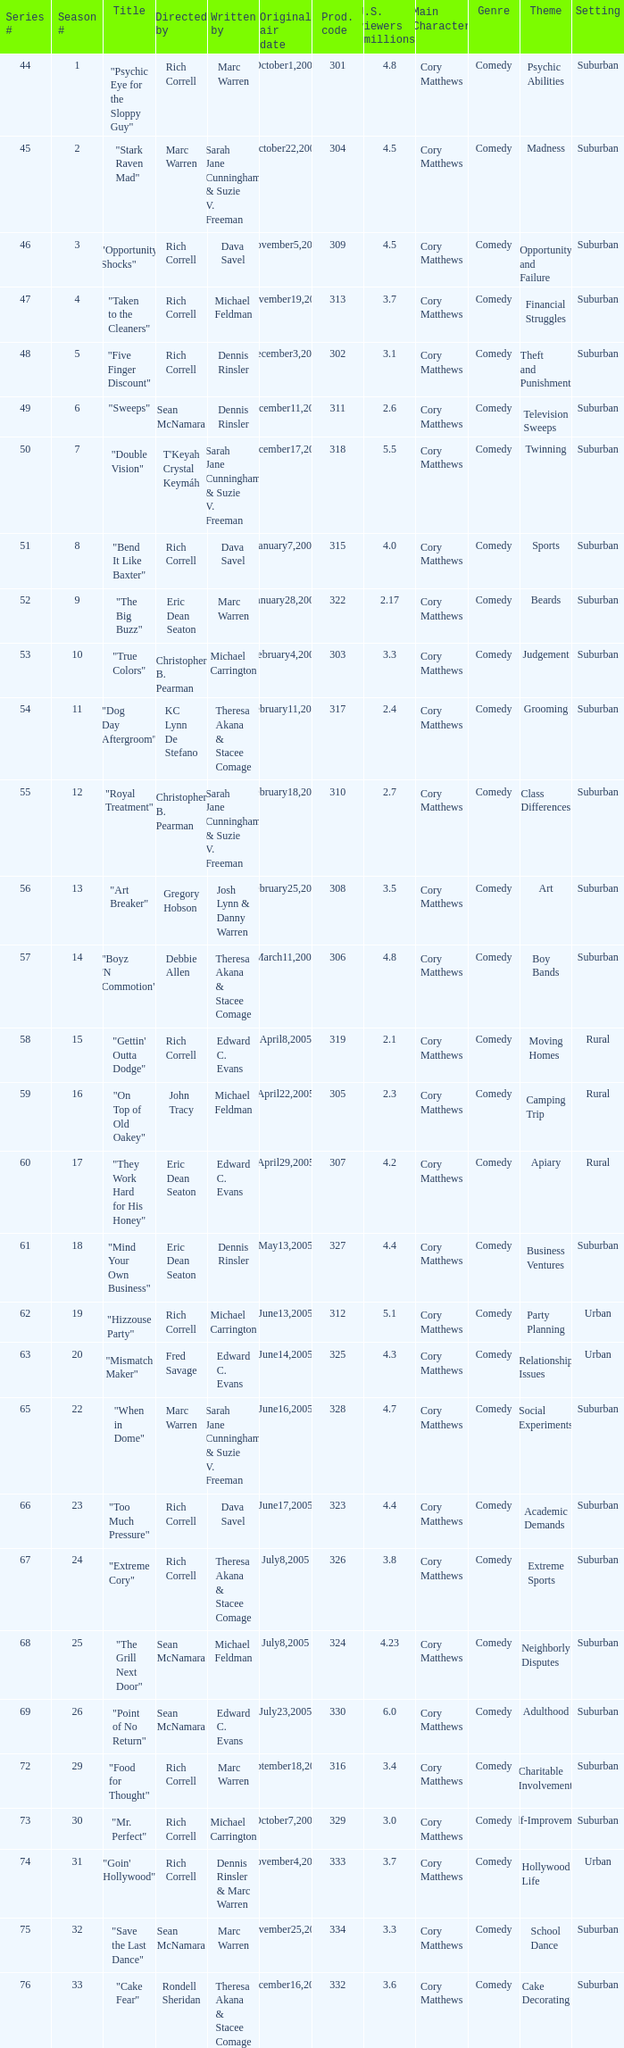What was the production code of the episode directed by Rondell Sheridan?  332.0. 